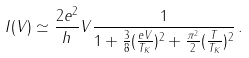Convert formula to latex. <formula><loc_0><loc_0><loc_500><loc_500>I ( V ) \simeq \frac { 2 e ^ { 2 } } { h } V \frac { 1 } { 1 + \frac { 3 } { 8 } ( \frac { e V } { T _ { K } } ) ^ { 2 } + \frac { \pi ^ { 2 } } { 2 } ( \frac { T } { T _ { K } } ) ^ { 2 } } \, .</formula> 